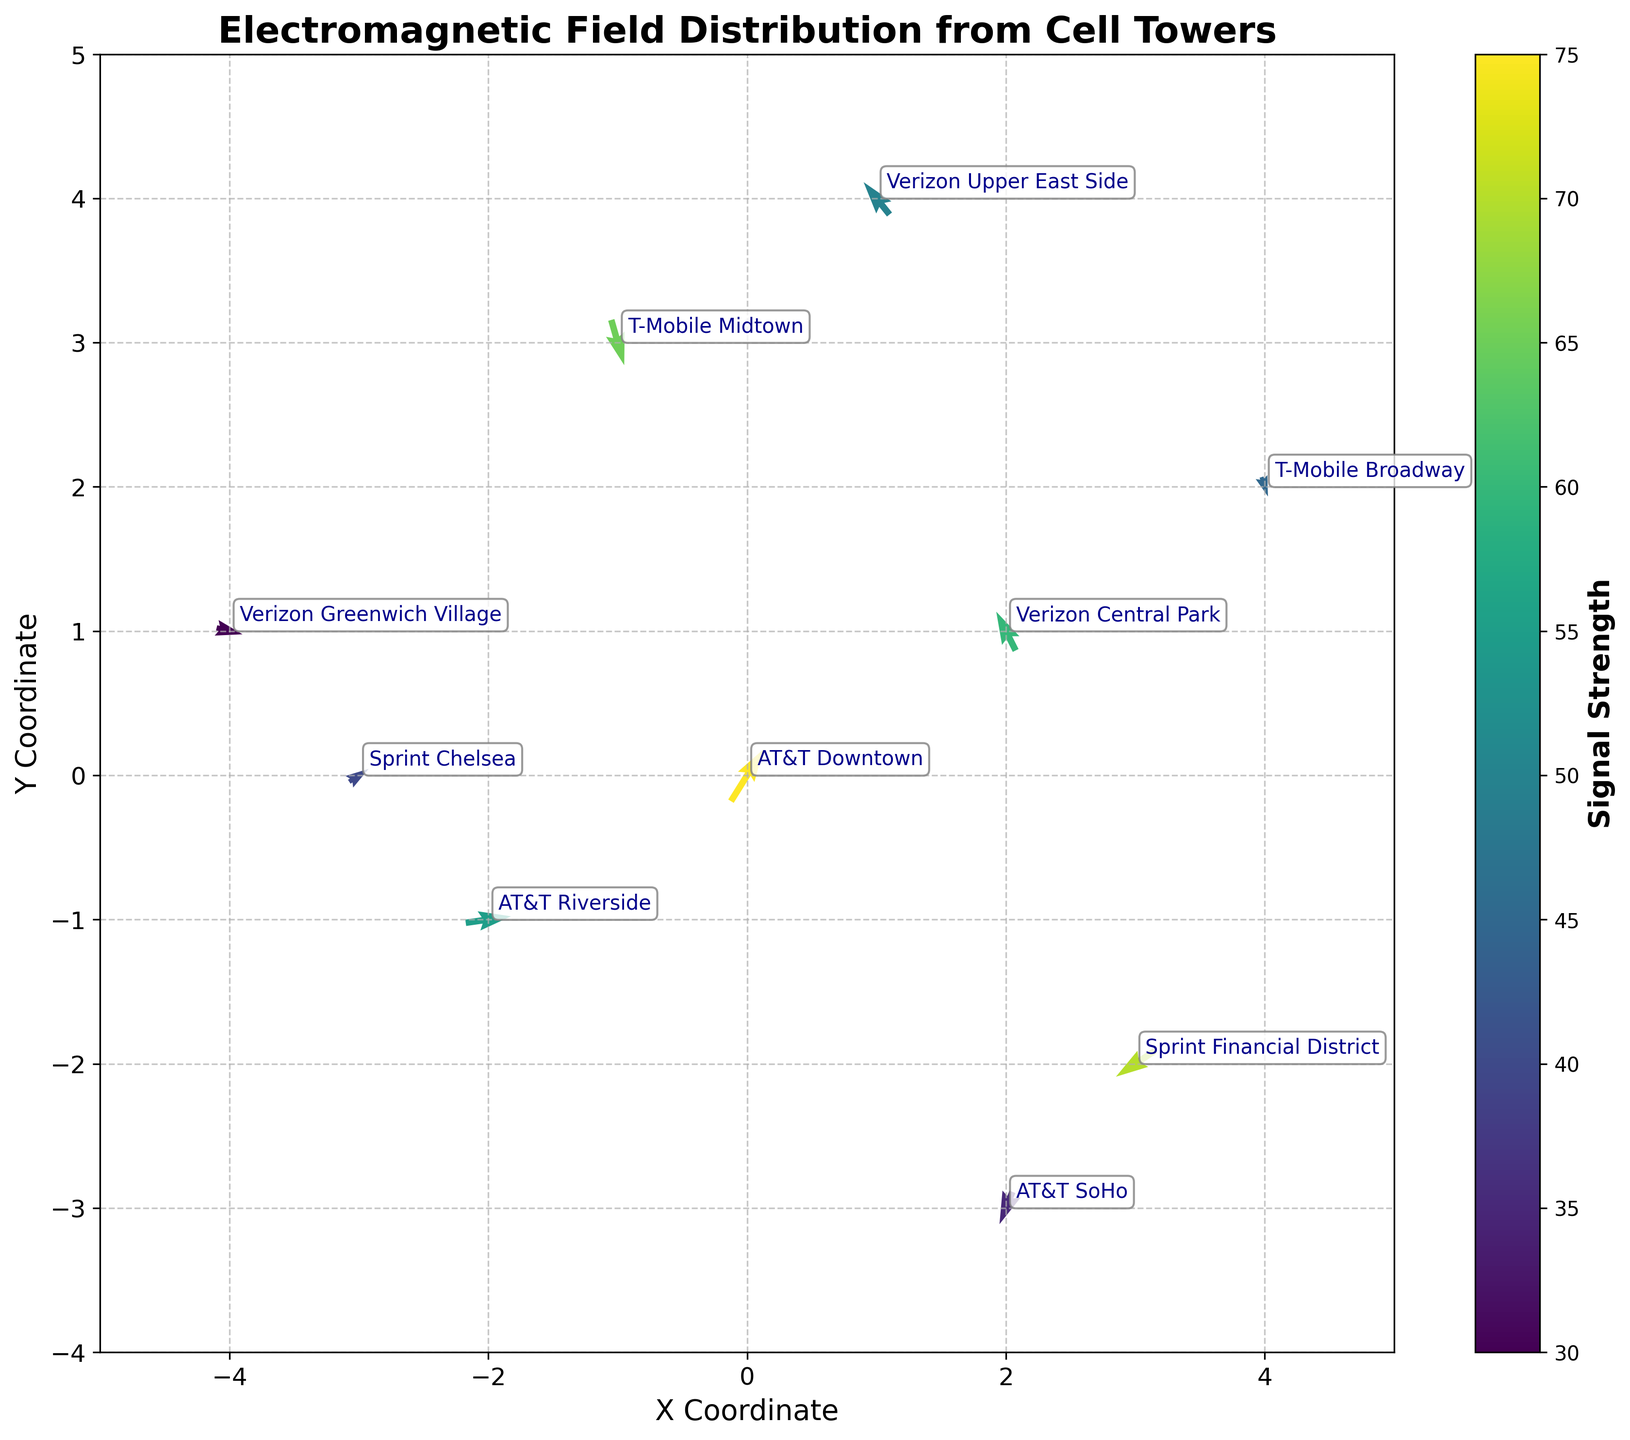What's the title of the plot? The title is usually displayed prominently at the top of the plot. Here, the title text is "Electromagnetic Field Distribution from Cell Towers."
Answer: Electromagnetic Field Distribution from Cell Towers How many data points (cell towers) are shown in the plot? Each cell tower corresponds to a specific set of coordinates (x, y) which is visually represented by a vector. There are 10 unique sets of coordinates given for the cell towers.
Answer: 10 What does the color represent in the plot? The color of the arrows represents the signal strength from the cell towers. This can be seen from the colorbar that is labeled "Signal Strength."
Answer: Signal strength What is the X coordinate of the Sprint Financial District cell tower? Locate the annotation for "Sprint Financial District" and refer to the corresponding X coordinate on the plot. It is situated at x = 3.
Answer: 3 Which cell tower has the highest signal strength and what is its strength? Look for the arrow with the strongest color intensity as per the colorbar. Annotations show that "AT&T Downtown" has the highest strength of 75.
Answer: AT&T Downtown, 75 Compare the direction of vectors of AT&T Downtown and Verizon Central Park. How do they differ? The AT&T Downtown vector has components (u, v) = (0.5, 0.8) pointing towards the right and upwards. The Verizon Central Park vector has components (u, v) = (-0.3, 0.6) pointing left and upwards. Thus, they differ in their horizontal directions.
Answer: AT&T Downtown points right and up, Verizon Central Park points left and up Which cell tower has the smallest signal strength and what is its direction? Identify the arrow with the weakest color intensity. Annotations show that "Verizon Greenwich Village" has the smallest strength of 30, with vector components (0.4, -0.1) pointing right and slightly down.
Answer: Verizon Greenwich Village, right and slightly down What is the average signal strength of the cell towers located at positive X coordinates? Identify the cell towers with x > 0: Verizon Central Park (60), AT&T SoHo (35), Sprint Financial District (70), and T-Mobile Broadway (45). Average strength is (60+35+70+45)/4 = 52.5.
Answer: 52.5 Are there any cell towers with vectors pointing directly downwards? A vector pointing directly downwards would have a (u, v) component of (0, negative value). None of the cell towers have such a vector; all vectors have a non-zero horizontal component.
Answer: No 